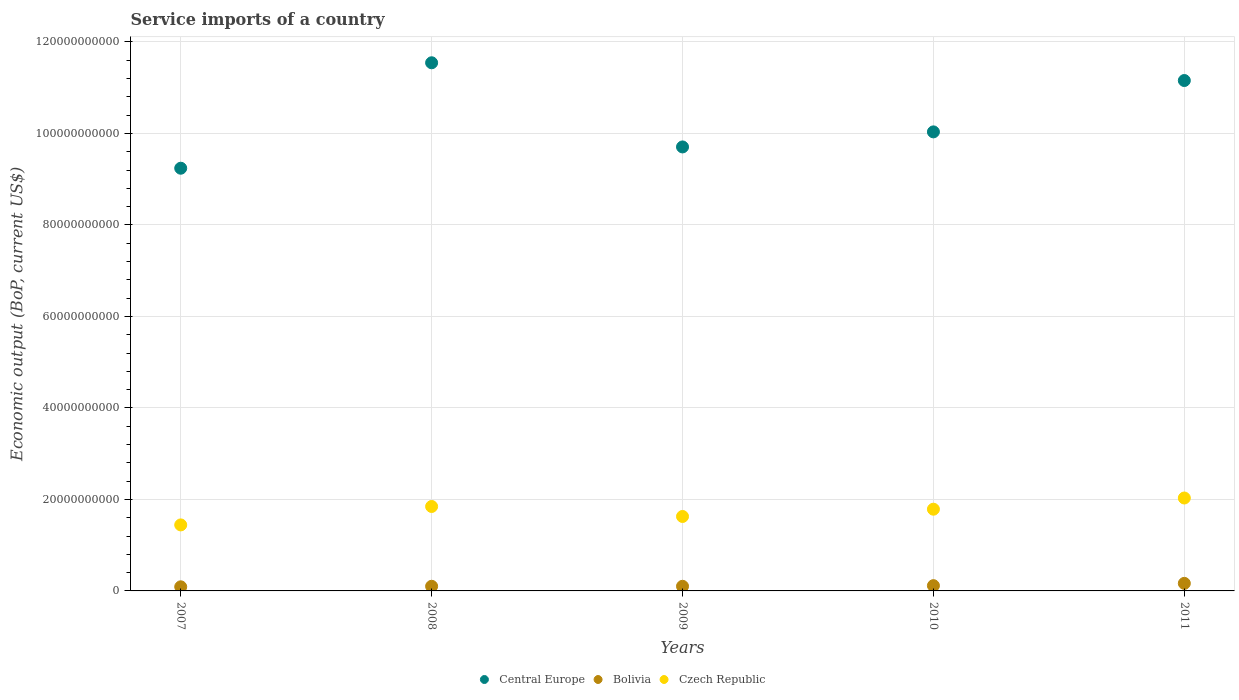Is the number of dotlines equal to the number of legend labels?
Provide a short and direct response. Yes. What is the service imports in Central Europe in 2007?
Your answer should be very brief. 9.24e+1. Across all years, what is the maximum service imports in Czech Republic?
Your response must be concise. 2.03e+1. Across all years, what is the minimum service imports in Bolivia?
Provide a succinct answer. 8.97e+08. What is the total service imports in Central Europe in the graph?
Your answer should be compact. 5.17e+11. What is the difference between the service imports in Bolivia in 2007 and that in 2009?
Make the answer very short. -1.15e+08. What is the difference between the service imports in Bolivia in 2009 and the service imports in Central Europe in 2007?
Make the answer very short. -9.14e+1. What is the average service imports in Bolivia per year?
Provide a short and direct response. 1.14e+09. In the year 2007, what is the difference between the service imports in Central Europe and service imports in Czech Republic?
Give a very brief answer. 7.80e+1. In how many years, is the service imports in Central Europe greater than 96000000000 US$?
Ensure brevity in your answer.  4. What is the ratio of the service imports in Central Europe in 2010 to that in 2011?
Offer a very short reply. 0.9. Is the service imports in Bolivia in 2007 less than that in 2008?
Your answer should be compact. Yes. Is the difference between the service imports in Central Europe in 2008 and 2010 greater than the difference between the service imports in Czech Republic in 2008 and 2010?
Give a very brief answer. Yes. What is the difference between the highest and the second highest service imports in Bolivia?
Offer a terse response. 5.02e+08. What is the difference between the highest and the lowest service imports in Central Europe?
Make the answer very short. 2.30e+1. In how many years, is the service imports in Central Europe greater than the average service imports in Central Europe taken over all years?
Give a very brief answer. 2. Is the service imports in Central Europe strictly less than the service imports in Czech Republic over the years?
Keep it short and to the point. No. How many dotlines are there?
Provide a short and direct response. 3. What is the difference between two consecutive major ticks on the Y-axis?
Your answer should be very brief. 2.00e+1. Are the values on the major ticks of Y-axis written in scientific E-notation?
Your answer should be very brief. No. Does the graph contain any zero values?
Offer a terse response. No. Does the graph contain grids?
Provide a short and direct response. Yes. Where does the legend appear in the graph?
Offer a terse response. Bottom center. How are the legend labels stacked?
Ensure brevity in your answer.  Horizontal. What is the title of the graph?
Give a very brief answer. Service imports of a country. Does "South Asia" appear as one of the legend labels in the graph?
Give a very brief answer. No. What is the label or title of the X-axis?
Your response must be concise. Years. What is the label or title of the Y-axis?
Provide a short and direct response. Economic output (BoP, current US$). What is the Economic output (BoP, current US$) in Central Europe in 2007?
Provide a succinct answer. 9.24e+1. What is the Economic output (BoP, current US$) of Bolivia in 2007?
Keep it short and to the point. 8.97e+08. What is the Economic output (BoP, current US$) of Czech Republic in 2007?
Ensure brevity in your answer.  1.44e+1. What is the Economic output (BoP, current US$) in Central Europe in 2008?
Keep it short and to the point. 1.15e+11. What is the Economic output (BoP, current US$) in Bolivia in 2008?
Keep it short and to the point. 1.01e+09. What is the Economic output (BoP, current US$) in Czech Republic in 2008?
Your response must be concise. 1.85e+1. What is the Economic output (BoP, current US$) of Central Europe in 2009?
Provide a short and direct response. 9.70e+1. What is the Economic output (BoP, current US$) of Bolivia in 2009?
Keep it short and to the point. 1.01e+09. What is the Economic output (BoP, current US$) in Czech Republic in 2009?
Offer a very short reply. 1.63e+1. What is the Economic output (BoP, current US$) in Central Europe in 2010?
Offer a terse response. 1.00e+11. What is the Economic output (BoP, current US$) of Bolivia in 2010?
Give a very brief answer. 1.15e+09. What is the Economic output (BoP, current US$) in Czech Republic in 2010?
Give a very brief answer. 1.79e+1. What is the Economic output (BoP, current US$) in Central Europe in 2011?
Provide a succinct answer. 1.12e+11. What is the Economic output (BoP, current US$) of Bolivia in 2011?
Offer a terse response. 1.65e+09. What is the Economic output (BoP, current US$) in Czech Republic in 2011?
Give a very brief answer. 2.03e+1. Across all years, what is the maximum Economic output (BoP, current US$) in Central Europe?
Your answer should be compact. 1.15e+11. Across all years, what is the maximum Economic output (BoP, current US$) of Bolivia?
Offer a very short reply. 1.65e+09. Across all years, what is the maximum Economic output (BoP, current US$) in Czech Republic?
Your answer should be compact. 2.03e+1. Across all years, what is the minimum Economic output (BoP, current US$) in Central Europe?
Your answer should be compact. 9.24e+1. Across all years, what is the minimum Economic output (BoP, current US$) in Bolivia?
Keep it short and to the point. 8.97e+08. Across all years, what is the minimum Economic output (BoP, current US$) of Czech Republic?
Ensure brevity in your answer.  1.44e+1. What is the total Economic output (BoP, current US$) in Central Europe in the graph?
Offer a very short reply. 5.17e+11. What is the total Economic output (BoP, current US$) in Bolivia in the graph?
Provide a short and direct response. 5.72e+09. What is the total Economic output (BoP, current US$) of Czech Republic in the graph?
Your answer should be very brief. 8.73e+1. What is the difference between the Economic output (BoP, current US$) in Central Europe in 2007 and that in 2008?
Offer a very short reply. -2.30e+1. What is the difference between the Economic output (BoP, current US$) in Bolivia in 2007 and that in 2008?
Provide a succinct answer. -1.17e+08. What is the difference between the Economic output (BoP, current US$) of Czech Republic in 2007 and that in 2008?
Offer a very short reply. -4.03e+09. What is the difference between the Economic output (BoP, current US$) in Central Europe in 2007 and that in 2009?
Your answer should be compact. -4.65e+09. What is the difference between the Economic output (BoP, current US$) of Bolivia in 2007 and that in 2009?
Provide a short and direct response. -1.15e+08. What is the difference between the Economic output (BoP, current US$) in Czech Republic in 2007 and that in 2009?
Your answer should be compact. -1.84e+09. What is the difference between the Economic output (BoP, current US$) of Central Europe in 2007 and that in 2010?
Provide a succinct answer. -7.94e+09. What is the difference between the Economic output (BoP, current US$) in Bolivia in 2007 and that in 2010?
Ensure brevity in your answer.  -2.52e+08. What is the difference between the Economic output (BoP, current US$) in Czech Republic in 2007 and that in 2010?
Your answer should be compact. -3.43e+09. What is the difference between the Economic output (BoP, current US$) of Central Europe in 2007 and that in 2011?
Offer a terse response. -1.92e+1. What is the difference between the Economic output (BoP, current US$) of Bolivia in 2007 and that in 2011?
Your response must be concise. -7.54e+08. What is the difference between the Economic output (BoP, current US$) of Czech Republic in 2007 and that in 2011?
Your response must be concise. -5.88e+09. What is the difference between the Economic output (BoP, current US$) in Central Europe in 2008 and that in 2009?
Keep it short and to the point. 1.84e+1. What is the difference between the Economic output (BoP, current US$) of Bolivia in 2008 and that in 2009?
Your answer should be compact. 1.81e+06. What is the difference between the Economic output (BoP, current US$) in Czech Republic in 2008 and that in 2009?
Provide a succinct answer. 2.18e+09. What is the difference between the Economic output (BoP, current US$) of Central Europe in 2008 and that in 2010?
Keep it short and to the point. 1.51e+1. What is the difference between the Economic output (BoP, current US$) of Bolivia in 2008 and that in 2010?
Provide a succinct answer. -1.35e+08. What is the difference between the Economic output (BoP, current US$) of Czech Republic in 2008 and that in 2010?
Keep it short and to the point. 5.93e+08. What is the difference between the Economic output (BoP, current US$) in Central Europe in 2008 and that in 2011?
Ensure brevity in your answer.  3.88e+09. What is the difference between the Economic output (BoP, current US$) in Bolivia in 2008 and that in 2011?
Offer a very short reply. -6.37e+08. What is the difference between the Economic output (BoP, current US$) in Czech Republic in 2008 and that in 2011?
Your answer should be compact. -1.85e+09. What is the difference between the Economic output (BoP, current US$) of Central Europe in 2009 and that in 2010?
Provide a succinct answer. -3.29e+09. What is the difference between the Economic output (BoP, current US$) of Bolivia in 2009 and that in 2010?
Keep it short and to the point. -1.37e+08. What is the difference between the Economic output (BoP, current US$) in Czech Republic in 2009 and that in 2010?
Offer a terse response. -1.59e+09. What is the difference between the Economic output (BoP, current US$) in Central Europe in 2009 and that in 2011?
Make the answer very short. -1.45e+1. What is the difference between the Economic output (BoP, current US$) of Bolivia in 2009 and that in 2011?
Keep it short and to the point. -6.39e+08. What is the difference between the Economic output (BoP, current US$) of Czech Republic in 2009 and that in 2011?
Offer a very short reply. -4.04e+09. What is the difference between the Economic output (BoP, current US$) of Central Europe in 2010 and that in 2011?
Ensure brevity in your answer.  -1.12e+1. What is the difference between the Economic output (BoP, current US$) in Bolivia in 2010 and that in 2011?
Offer a very short reply. -5.02e+08. What is the difference between the Economic output (BoP, current US$) of Czech Republic in 2010 and that in 2011?
Offer a terse response. -2.45e+09. What is the difference between the Economic output (BoP, current US$) in Central Europe in 2007 and the Economic output (BoP, current US$) in Bolivia in 2008?
Your answer should be very brief. 9.14e+1. What is the difference between the Economic output (BoP, current US$) of Central Europe in 2007 and the Economic output (BoP, current US$) of Czech Republic in 2008?
Ensure brevity in your answer.  7.39e+1. What is the difference between the Economic output (BoP, current US$) in Bolivia in 2007 and the Economic output (BoP, current US$) in Czech Republic in 2008?
Provide a short and direct response. -1.76e+1. What is the difference between the Economic output (BoP, current US$) in Central Europe in 2007 and the Economic output (BoP, current US$) in Bolivia in 2009?
Offer a very short reply. 9.14e+1. What is the difference between the Economic output (BoP, current US$) of Central Europe in 2007 and the Economic output (BoP, current US$) of Czech Republic in 2009?
Offer a terse response. 7.61e+1. What is the difference between the Economic output (BoP, current US$) of Bolivia in 2007 and the Economic output (BoP, current US$) of Czech Republic in 2009?
Provide a succinct answer. -1.54e+1. What is the difference between the Economic output (BoP, current US$) of Central Europe in 2007 and the Economic output (BoP, current US$) of Bolivia in 2010?
Your response must be concise. 9.12e+1. What is the difference between the Economic output (BoP, current US$) of Central Europe in 2007 and the Economic output (BoP, current US$) of Czech Republic in 2010?
Offer a terse response. 7.45e+1. What is the difference between the Economic output (BoP, current US$) in Bolivia in 2007 and the Economic output (BoP, current US$) in Czech Republic in 2010?
Offer a terse response. -1.70e+1. What is the difference between the Economic output (BoP, current US$) in Central Europe in 2007 and the Economic output (BoP, current US$) in Bolivia in 2011?
Provide a short and direct response. 9.07e+1. What is the difference between the Economic output (BoP, current US$) in Central Europe in 2007 and the Economic output (BoP, current US$) in Czech Republic in 2011?
Provide a succinct answer. 7.21e+1. What is the difference between the Economic output (BoP, current US$) in Bolivia in 2007 and the Economic output (BoP, current US$) in Czech Republic in 2011?
Your response must be concise. -1.94e+1. What is the difference between the Economic output (BoP, current US$) of Central Europe in 2008 and the Economic output (BoP, current US$) of Bolivia in 2009?
Offer a very short reply. 1.14e+11. What is the difference between the Economic output (BoP, current US$) of Central Europe in 2008 and the Economic output (BoP, current US$) of Czech Republic in 2009?
Ensure brevity in your answer.  9.92e+1. What is the difference between the Economic output (BoP, current US$) of Bolivia in 2008 and the Economic output (BoP, current US$) of Czech Republic in 2009?
Your answer should be compact. -1.53e+1. What is the difference between the Economic output (BoP, current US$) of Central Europe in 2008 and the Economic output (BoP, current US$) of Bolivia in 2010?
Offer a terse response. 1.14e+11. What is the difference between the Economic output (BoP, current US$) of Central Europe in 2008 and the Economic output (BoP, current US$) of Czech Republic in 2010?
Your answer should be compact. 9.76e+1. What is the difference between the Economic output (BoP, current US$) of Bolivia in 2008 and the Economic output (BoP, current US$) of Czech Republic in 2010?
Provide a succinct answer. -1.68e+1. What is the difference between the Economic output (BoP, current US$) of Central Europe in 2008 and the Economic output (BoP, current US$) of Bolivia in 2011?
Ensure brevity in your answer.  1.14e+11. What is the difference between the Economic output (BoP, current US$) of Central Europe in 2008 and the Economic output (BoP, current US$) of Czech Republic in 2011?
Give a very brief answer. 9.51e+1. What is the difference between the Economic output (BoP, current US$) in Bolivia in 2008 and the Economic output (BoP, current US$) in Czech Republic in 2011?
Your answer should be very brief. -1.93e+1. What is the difference between the Economic output (BoP, current US$) in Central Europe in 2009 and the Economic output (BoP, current US$) in Bolivia in 2010?
Make the answer very short. 9.59e+1. What is the difference between the Economic output (BoP, current US$) in Central Europe in 2009 and the Economic output (BoP, current US$) in Czech Republic in 2010?
Give a very brief answer. 7.92e+1. What is the difference between the Economic output (BoP, current US$) of Bolivia in 2009 and the Economic output (BoP, current US$) of Czech Republic in 2010?
Keep it short and to the point. -1.69e+1. What is the difference between the Economic output (BoP, current US$) in Central Europe in 2009 and the Economic output (BoP, current US$) in Bolivia in 2011?
Give a very brief answer. 9.54e+1. What is the difference between the Economic output (BoP, current US$) of Central Europe in 2009 and the Economic output (BoP, current US$) of Czech Republic in 2011?
Ensure brevity in your answer.  7.67e+1. What is the difference between the Economic output (BoP, current US$) in Bolivia in 2009 and the Economic output (BoP, current US$) in Czech Republic in 2011?
Your answer should be very brief. -1.93e+1. What is the difference between the Economic output (BoP, current US$) of Central Europe in 2010 and the Economic output (BoP, current US$) of Bolivia in 2011?
Keep it short and to the point. 9.87e+1. What is the difference between the Economic output (BoP, current US$) of Central Europe in 2010 and the Economic output (BoP, current US$) of Czech Republic in 2011?
Your answer should be very brief. 8.00e+1. What is the difference between the Economic output (BoP, current US$) in Bolivia in 2010 and the Economic output (BoP, current US$) in Czech Republic in 2011?
Offer a very short reply. -1.92e+1. What is the average Economic output (BoP, current US$) in Central Europe per year?
Your answer should be compact. 1.03e+11. What is the average Economic output (BoP, current US$) in Bolivia per year?
Give a very brief answer. 1.14e+09. What is the average Economic output (BoP, current US$) in Czech Republic per year?
Keep it short and to the point. 1.75e+1. In the year 2007, what is the difference between the Economic output (BoP, current US$) in Central Europe and Economic output (BoP, current US$) in Bolivia?
Ensure brevity in your answer.  9.15e+1. In the year 2007, what is the difference between the Economic output (BoP, current US$) in Central Europe and Economic output (BoP, current US$) in Czech Republic?
Give a very brief answer. 7.80e+1. In the year 2007, what is the difference between the Economic output (BoP, current US$) of Bolivia and Economic output (BoP, current US$) of Czech Republic?
Keep it short and to the point. -1.35e+1. In the year 2008, what is the difference between the Economic output (BoP, current US$) in Central Europe and Economic output (BoP, current US$) in Bolivia?
Your response must be concise. 1.14e+11. In the year 2008, what is the difference between the Economic output (BoP, current US$) of Central Europe and Economic output (BoP, current US$) of Czech Republic?
Ensure brevity in your answer.  9.70e+1. In the year 2008, what is the difference between the Economic output (BoP, current US$) of Bolivia and Economic output (BoP, current US$) of Czech Republic?
Ensure brevity in your answer.  -1.74e+1. In the year 2009, what is the difference between the Economic output (BoP, current US$) of Central Europe and Economic output (BoP, current US$) of Bolivia?
Give a very brief answer. 9.60e+1. In the year 2009, what is the difference between the Economic output (BoP, current US$) of Central Europe and Economic output (BoP, current US$) of Czech Republic?
Give a very brief answer. 8.08e+1. In the year 2009, what is the difference between the Economic output (BoP, current US$) in Bolivia and Economic output (BoP, current US$) in Czech Republic?
Your answer should be compact. -1.53e+1. In the year 2010, what is the difference between the Economic output (BoP, current US$) in Central Europe and Economic output (BoP, current US$) in Bolivia?
Offer a terse response. 9.92e+1. In the year 2010, what is the difference between the Economic output (BoP, current US$) in Central Europe and Economic output (BoP, current US$) in Czech Republic?
Provide a short and direct response. 8.25e+1. In the year 2010, what is the difference between the Economic output (BoP, current US$) of Bolivia and Economic output (BoP, current US$) of Czech Republic?
Your answer should be compact. -1.67e+1. In the year 2011, what is the difference between the Economic output (BoP, current US$) in Central Europe and Economic output (BoP, current US$) in Bolivia?
Offer a very short reply. 1.10e+11. In the year 2011, what is the difference between the Economic output (BoP, current US$) in Central Europe and Economic output (BoP, current US$) in Czech Republic?
Your answer should be very brief. 9.13e+1. In the year 2011, what is the difference between the Economic output (BoP, current US$) of Bolivia and Economic output (BoP, current US$) of Czech Republic?
Your response must be concise. -1.87e+1. What is the ratio of the Economic output (BoP, current US$) of Central Europe in 2007 to that in 2008?
Give a very brief answer. 0.8. What is the ratio of the Economic output (BoP, current US$) of Bolivia in 2007 to that in 2008?
Your answer should be compact. 0.88. What is the ratio of the Economic output (BoP, current US$) in Czech Republic in 2007 to that in 2008?
Your answer should be compact. 0.78. What is the ratio of the Economic output (BoP, current US$) of Central Europe in 2007 to that in 2009?
Provide a short and direct response. 0.95. What is the ratio of the Economic output (BoP, current US$) of Bolivia in 2007 to that in 2009?
Ensure brevity in your answer.  0.89. What is the ratio of the Economic output (BoP, current US$) of Czech Republic in 2007 to that in 2009?
Keep it short and to the point. 0.89. What is the ratio of the Economic output (BoP, current US$) of Central Europe in 2007 to that in 2010?
Give a very brief answer. 0.92. What is the ratio of the Economic output (BoP, current US$) in Bolivia in 2007 to that in 2010?
Provide a short and direct response. 0.78. What is the ratio of the Economic output (BoP, current US$) of Czech Republic in 2007 to that in 2010?
Your response must be concise. 0.81. What is the ratio of the Economic output (BoP, current US$) of Central Europe in 2007 to that in 2011?
Your answer should be very brief. 0.83. What is the ratio of the Economic output (BoP, current US$) of Bolivia in 2007 to that in 2011?
Offer a terse response. 0.54. What is the ratio of the Economic output (BoP, current US$) of Czech Republic in 2007 to that in 2011?
Offer a very short reply. 0.71. What is the ratio of the Economic output (BoP, current US$) in Central Europe in 2008 to that in 2009?
Provide a short and direct response. 1.19. What is the ratio of the Economic output (BoP, current US$) of Bolivia in 2008 to that in 2009?
Offer a terse response. 1. What is the ratio of the Economic output (BoP, current US$) in Czech Republic in 2008 to that in 2009?
Give a very brief answer. 1.13. What is the ratio of the Economic output (BoP, current US$) of Central Europe in 2008 to that in 2010?
Offer a terse response. 1.15. What is the ratio of the Economic output (BoP, current US$) of Bolivia in 2008 to that in 2010?
Keep it short and to the point. 0.88. What is the ratio of the Economic output (BoP, current US$) in Czech Republic in 2008 to that in 2010?
Your answer should be compact. 1.03. What is the ratio of the Economic output (BoP, current US$) of Central Europe in 2008 to that in 2011?
Keep it short and to the point. 1.03. What is the ratio of the Economic output (BoP, current US$) of Bolivia in 2008 to that in 2011?
Provide a succinct answer. 0.61. What is the ratio of the Economic output (BoP, current US$) of Czech Republic in 2008 to that in 2011?
Provide a short and direct response. 0.91. What is the ratio of the Economic output (BoP, current US$) of Central Europe in 2009 to that in 2010?
Give a very brief answer. 0.97. What is the ratio of the Economic output (BoP, current US$) of Bolivia in 2009 to that in 2010?
Provide a succinct answer. 0.88. What is the ratio of the Economic output (BoP, current US$) in Czech Republic in 2009 to that in 2010?
Offer a very short reply. 0.91. What is the ratio of the Economic output (BoP, current US$) in Central Europe in 2009 to that in 2011?
Give a very brief answer. 0.87. What is the ratio of the Economic output (BoP, current US$) in Bolivia in 2009 to that in 2011?
Provide a short and direct response. 0.61. What is the ratio of the Economic output (BoP, current US$) in Czech Republic in 2009 to that in 2011?
Your answer should be very brief. 0.8. What is the ratio of the Economic output (BoP, current US$) of Central Europe in 2010 to that in 2011?
Provide a succinct answer. 0.9. What is the ratio of the Economic output (BoP, current US$) in Bolivia in 2010 to that in 2011?
Ensure brevity in your answer.  0.7. What is the ratio of the Economic output (BoP, current US$) of Czech Republic in 2010 to that in 2011?
Offer a very short reply. 0.88. What is the difference between the highest and the second highest Economic output (BoP, current US$) in Central Europe?
Keep it short and to the point. 3.88e+09. What is the difference between the highest and the second highest Economic output (BoP, current US$) in Bolivia?
Your answer should be very brief. 5.02e+08. What is the difference between the highest and the second highest Economic output (BoP, current US$) of Czech Republic?
Offer a very short reply. 1.85e+09. What is the difference between the highest and the lowest Economic output (BoP, current US$) of Central Europe?
Keep it short and to the point. 2.30e+1. What is the difference between the highest and the lowest Economic output (BoP, current US$) of Bolivia?
Your answer should be very brief. 7.54e+08. What is the difference between the highest and the lowest Economic output (BoP, current US$) of Czech Republic?
Make the answer very short. 5.88e+09. 